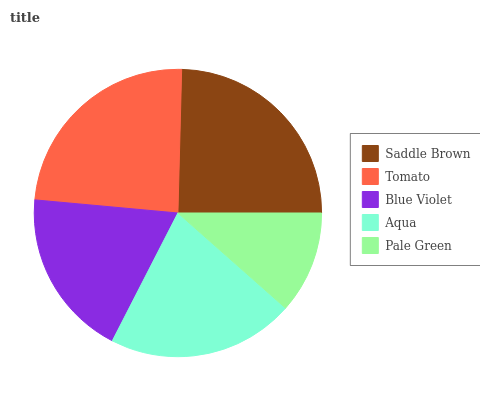Is Pale Green the minimum?
Answer yes or no. Yes. Is Saddle Brown the maximum?
Answer yes or no. Yes. Is Tomato the minimum?
Answer yes or no. No. Is Tomato the maximum?
Answer yes or no. No. Is Saddle Brown greater than Tomato?
Answer yes or no. Yes. Is Tomato less than Saddle Brown?
Answer yes or no. Yes. Is Tomato greater than Saddle Brown?
Answer yes or no. No. Is Saddle Brown less than Tomato?
Answer yes or no. No. Is Aqua the high median?
Answer yes or no. Yes. Is Aqua the low median?
Answer yes or no. Yes. Is Saddle Brown the high median?
Answer yes or no. No. Is Tomato the low median?
Answer yes or no. No. 